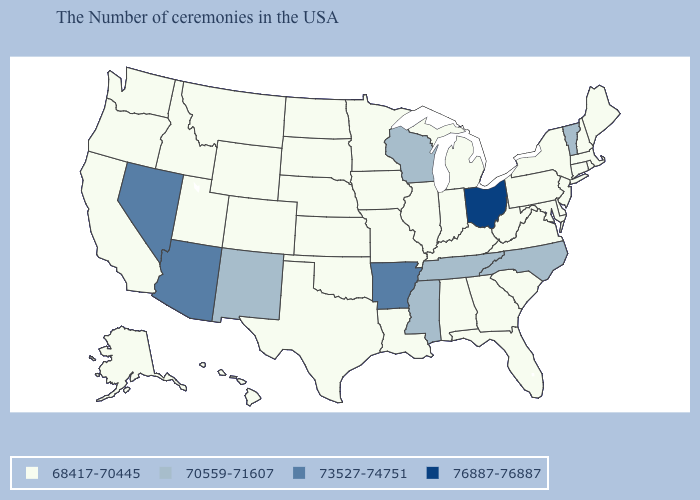Does Delaware have the same value as New Mexico?
Short answer required. No. Among the states that border Washington , which have the highest value?
Short answer required. Idaho, Oregon. Which states have the lowest value in the West?
Keep it brief. Wyoming, Colorado, Utah, Montana, Idaho, California, Washington, Oregon, Alaska, Hawaii. What is the value of New York?
Quick response, please. 68417-70445. Name the states that have a value in the range 73527-74751?
Quick response, please. Arkansas, Arizona, Nevada. Name the states that have a value in the range 70559-71607?
Write a very short answer. Vermont, North Carolina, Tennessee, Wisconsin, Mississippi, New Mexico. Does the first symbol in the legend represent the smallest category?
Be succinct. Yes. Which states have the lowest value in the West?
Concise answer only. Wyoming, Colorado, Utah, Montana, Idaho, California, Washington, Oregon, Alaska, Hawaii. Name the states that have a value in the range 76887-76887?
Write a very short answer. Ohio. Does Iowa have the lowest value in the USA?
Keep it brief. Yes. How many symbols are there in the legend?
Concise answer only. 4. Is the legend a continuous bar?
Write a very short answer. No. Among the states that border Wyoming , which have the lowest value?
Write a very short answer. Nebraska, South Dakota, Colorado, Utah, Montana, Idaho. Is the legend a continuous bar?
Answer briefly. No. Name the states that have a value in the range 68417-70445?
Write a very short answer. Maine, Massachusetts, Rhode Island, New Hampshire, Connecticut, New York, New Jersey, Delaware, Maryland, Pennsylvania, Virginia, South Carolina, West Virginia, Florida, Georgia, Michigan, Kentucky, Indiana, Alabama, Illinois, Louisiana, Missouri, Minnesota, Iowa, Kansas, Nebraska, Oklahoma, Texas, South Dakota, North Dakota, Wyoming, Colorado, Utah, Montana, Idaho, California, Washington, Oregon, Alaska, Hawaii. 